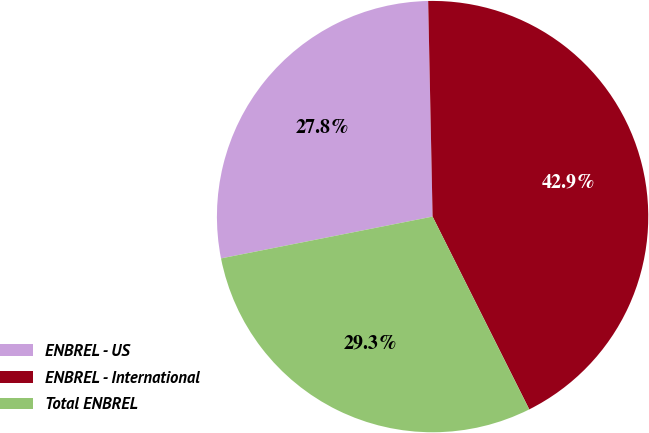<chart> <loc_0><loc_0><loc_500><loc_500><pie_chart><fcel>ENBREL - US<fcel>ENBREL - International<fcel>Total ENBREL<nl><fcel>27.78%<fcel>42.93%<fcel>29.29%<nl></chart> 